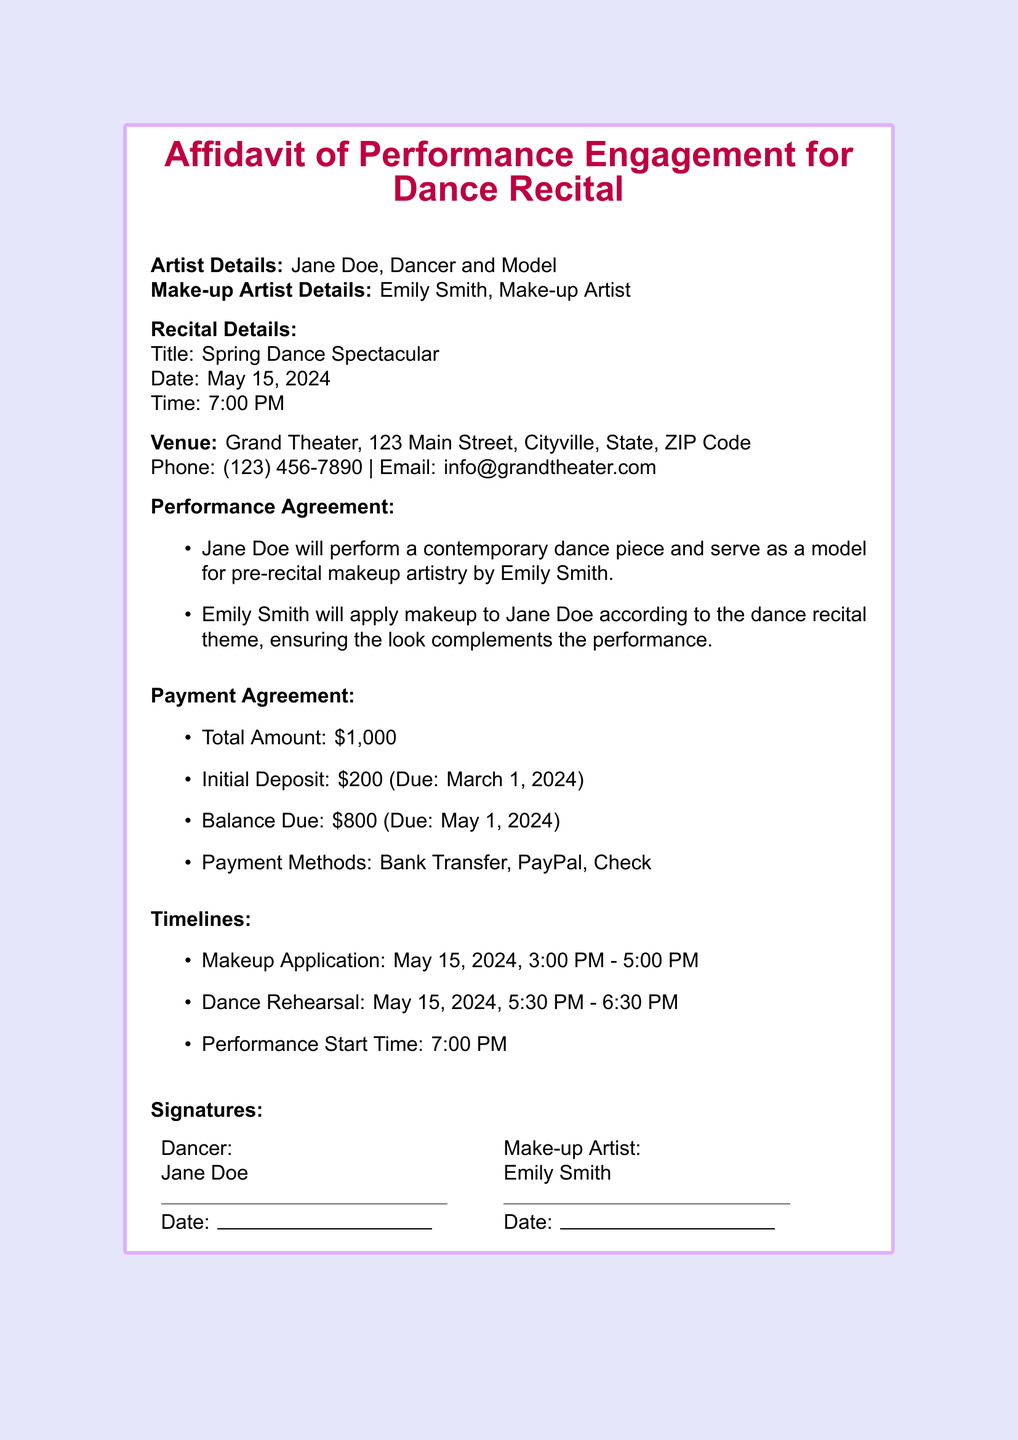what is the artist's name? The artist's name is provided in the "Artist Details" section of the document.
Answer: Jane Doe what is the performance date? The performance date is stated under "Recital Details" in the document.
Answer: May 15, 2024 where is the venue located? The venue location is listed in the "Venue" section of the document with the full address.
Answer: Grand Theater, 123 Main Street, Cityville, State, ZIP Code how much is the total payment? The total payment amount is provided in the "Payment Agreement" section of the document.
Answer: $1,000 when is the initial deposit due? The due date for the initial deposit is mentioned in the "Payment Agreement" section.
Answer: March 1, 2024 what time is the performance start? The performance start time is detailed in the "Timelines" section of the document.
Answer: 7:00 PM who will apply the makeup? The makeup artist's name is specified in the document under the "Make-up Artist Details."
Answer: Emily Smith what time is the makeup application scheduled? The scheduled time for makeup application is mentioned in the "Timelines" section.
Answer: 3:00 PM - 5:00 PM what type of dance will Jane Doe perform? The type of dance Jane Doe will perform is stated in the "Performance Agreement."
Answer: contemporary dance piece 